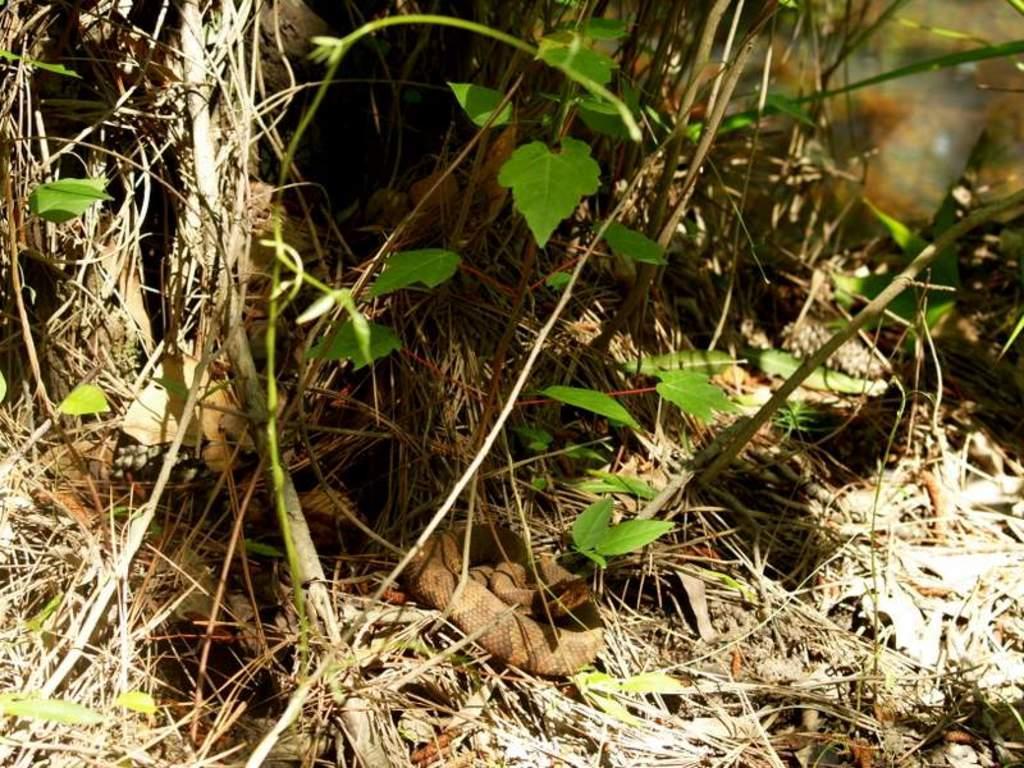Can you describe this image briefly? In the center of the image there is a snake on the ground. In the background there are plants and trees. 